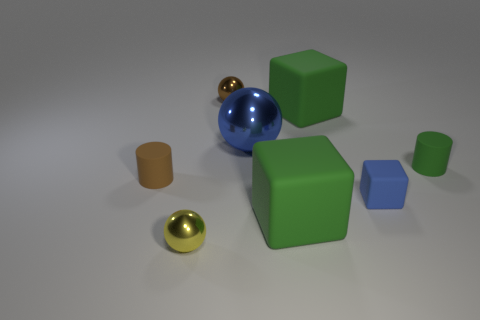Are there any other things that are the same color as the big metallic sphere?
Provide a succinct answer. Yes. There is a tiny green thing that is the same material as the tiny blue thing; what is its shape?
Offer a terse response. Cylinder. What is the small cylinder on the right side of the large matte thing behind the blue matte thing made of?
Keep it short and to the point. Rubber. Do the thing that is left of the small yellow sphere and the big blue metallic thing have the same shape?
Your answer should be very brief. No. Is the number of metal spheres to the right of the small yellow shiny object greater than the number of red rubber objects?
Ensure brevity in your answer.  Yes. Are there any other things that are the same material as the small yellow ball?
Offer a terse response. Yes. What shape is the large metal object that is the same color as the tiny rubber block?
Your answer should be very brief. Sphere. How many blocks are either small metal things or small blue things?
Your answer should be compact. 1. The small matte object that is on the left side of the blue matte object behind the tiny yellow shiny thing is what color?
Offer a very short reply. Brown. Does the small matte block have the same color as the tiny matte thing that is on the left side of the yellow metallic thing?
Offer a terse response. No. 